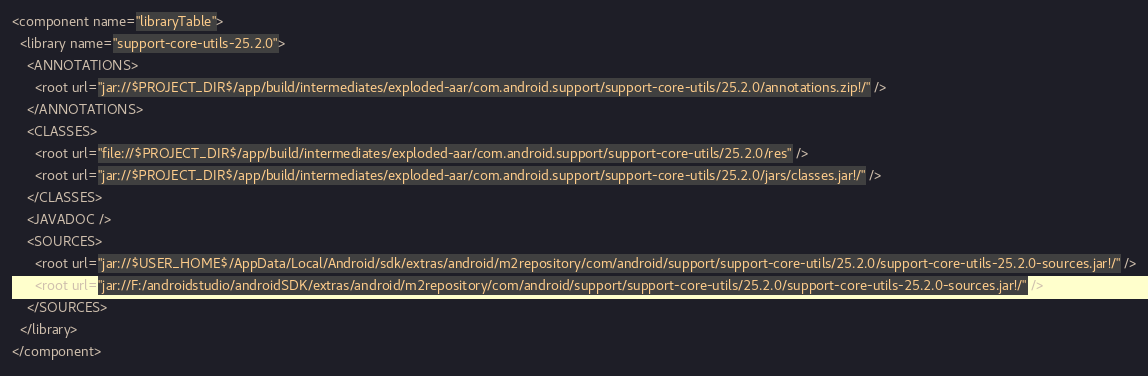Convert code to text. <code><loc_0><loc_0><loc_500><loc_500><_XML_><component name="libraryTable">
  <library name="support-core-utils-25.2.0">
    <ANNOTATIONS>
      <root url="jar://$PROJECT_DIR$/app/build/intermediates/exploded-aar/com.android.support/support-core-utils/25.2.0/annotations.zip!/" />
    </ANNOTATIONS>
    <CLASSES>
      <root url="file://$PROJECT_DIR$/app/build/intermediates/exploded-aar/com.android.support/support-core-utils/25.2.0/res" />
      <root url="jar://$PROJECT_DIR$/app/build/intermediates/exploded-aar/com.android.support/support-core-utils/25.2.0/jars/classes.jar!/" />
    </CLASSES>
    <JAVADOC />
    <SOURCES>
      <root url="jar://$USER_HOME$/AppData/Local/Android/sdk/extras/android/m2repository/com/android/support/support-core-utils/25.2.0/support-core-utils-25.2.0-sources.jar!/" />
      <root url="jar://F:/androidstudio/androidSDK/extras/android/m2repository/com/android/support/support-core-utils/25.2.0/support-core-utils-25.2.0-sources.jar!/" />
    </SOURCES>
  </library>
</component></code> 